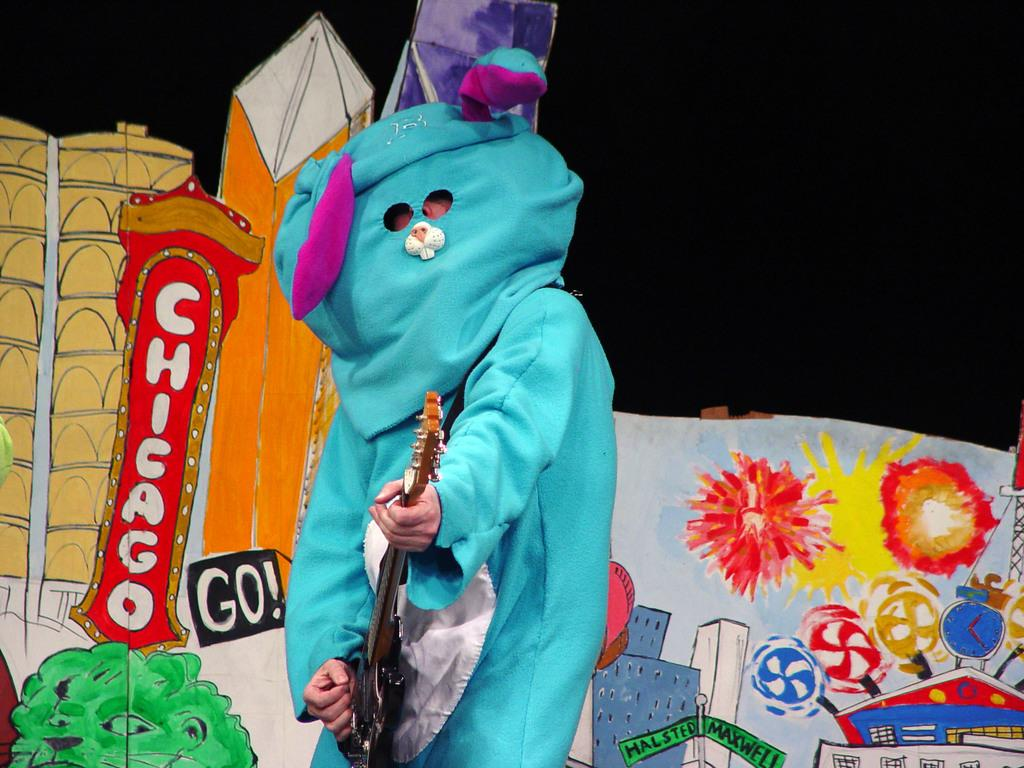What is the main subject of the image? There is a person in the image. What is the person wearing? The person is wearing a cartoon costume. What object is the person holding? The person is holding a guitar. Can you describe the background of the image? There is a colorful background in the image. How long does it take for the sponge to dry in the image? There is no sponge present in the image. 